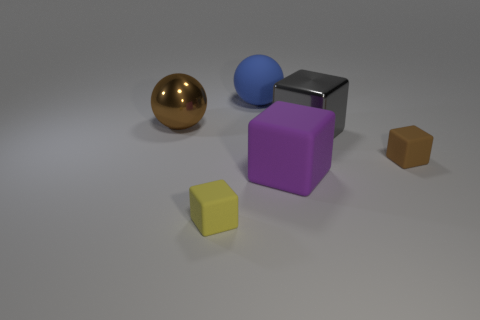What number of matte things are large balls or tiny yellow cylinders?
Offer a very short reply. 1. There is a purple thing that is the same material as the small brown cube; what is its shape?
Give a very brief answer. Cube. How many big matte objects are both behind the metallic ball and right of the blue thing?
Your answer should be very brief. 0. Is there anything else that has the same shape as the brown shiny object?
Provide a succinct answer. Yes. There is a blue thing that is on the left side of the gray object; what is its size?
Provide a succinct answer. Large. What number of other things are the same color as the big metallic ball?
Offer a very short reply. 1. What material is the big cube that is in front of the rubber cube that is behind the purple matte object?
Give a very brief answer. Rubber. Does the tiny matte cube that is on the right side of the big matte cube have the same color as the big metal ball?
Provide a short and direct response. Yes. Is there any other thing that is the same material as the big purple block?
Your answer should be very brief. Yes. How many other tiny rubber things are the same shape as the purple object?
Provide a succinct answer. 2. 